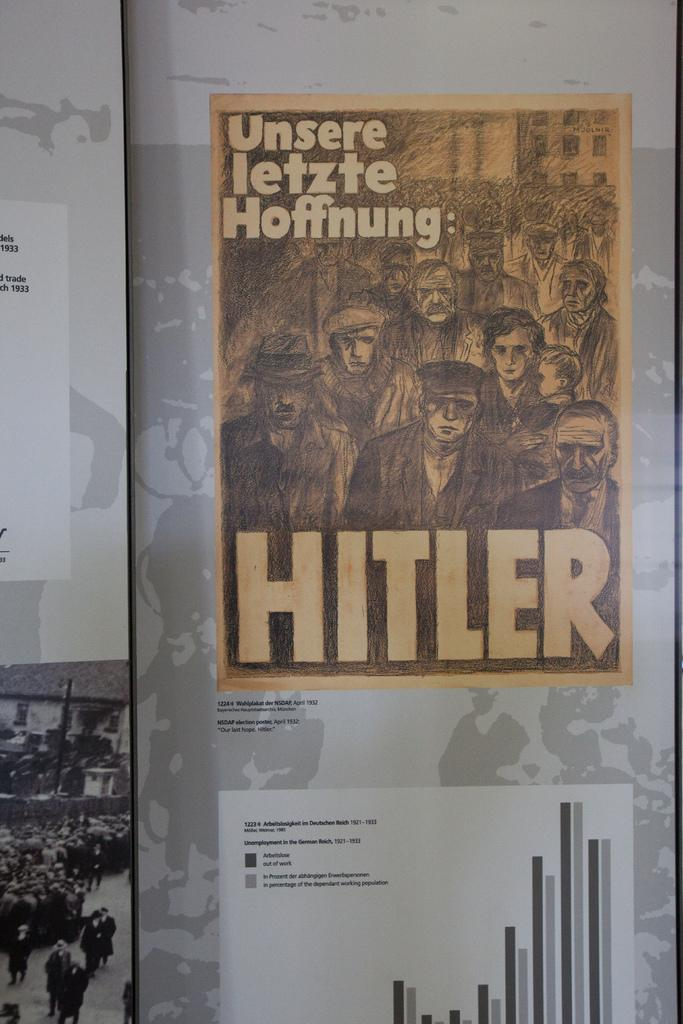Provide a one-sentence caption for the provided image. Poster hung that show Hitler and graphs that german people were included in. 